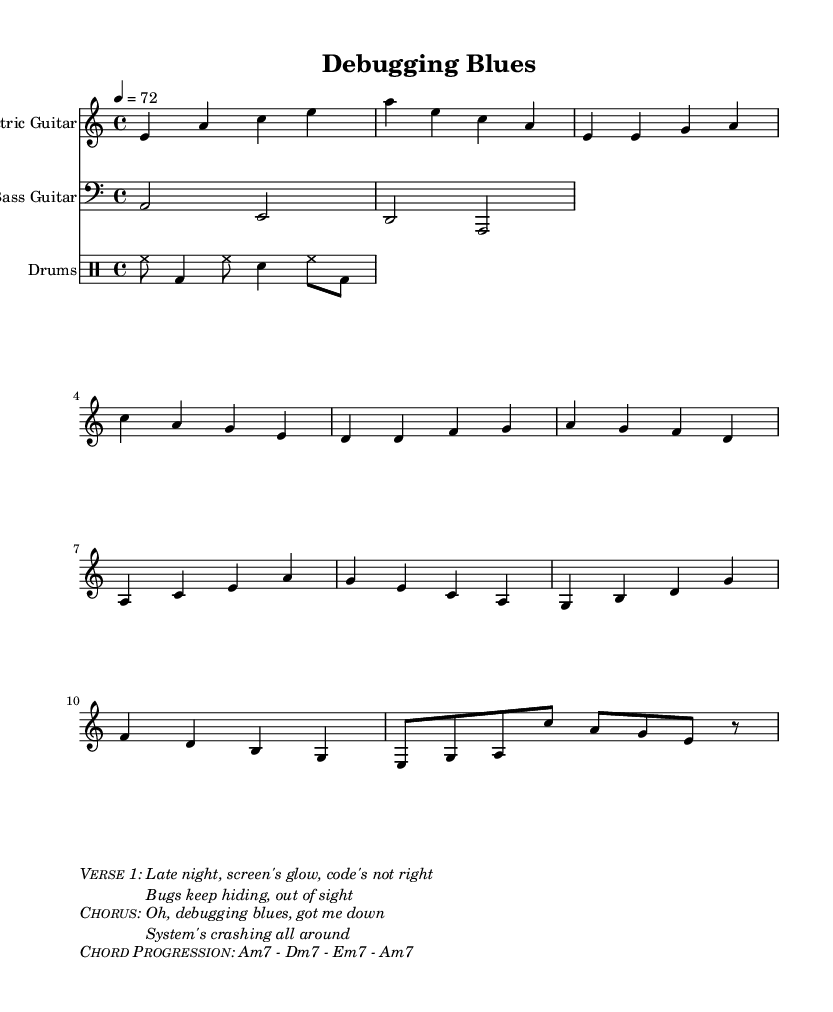What is the key signature of this music? The key signature is represented by the number of sharps or flats at the beginning of the staff. Here, it shows A minor, which is the relative minor of C major and has no sharps or flats.
Answer: A minor What is the time signature of this music? The time signature is displayed in the staff at the beginning of the piece. It indicates the number of beats in a measure and the note value that represents one beat. Here, it is shown as 4/4, meaning four beats per measure with the quarter note receiving one beat.
Answer: 4/4 What is the tempo marking of this music? The tempo marking can be found at the beginning, indicating how fast the music should be played. It says "4 = 72", meaning the quarter note should be played at a speed of 72 beats per minute.
Answer: 72 What is the chord progression mentioned in the music? The chord progression is specified within the markup section, which details which chords should be played during the different sections of the song. The chords listed are Am7, Dm7, Em7, and Am7.
Answer: Am7 - Dm7 - Em7 - Am7 What is the emotional theme reflected in the lyrics of the verse? The emotional theme can be inferred from the lyrics provided in the markup. They express frustration and the struggles associated with debugging, indicating a sense of feeling lost and challenged while working on complex systems.
Answer: Frustration How does the structure of the song reflect typical elements of Electric Blues? Electric Blues often follows a specific song structure, including verses and a chorus, showcasing emotional themes often linked to personal struggles. This song features a distinct verse and chorus layout reflecting these elements, in addition to the signature electric guitar riff.
Answer: Verse and Chorus 